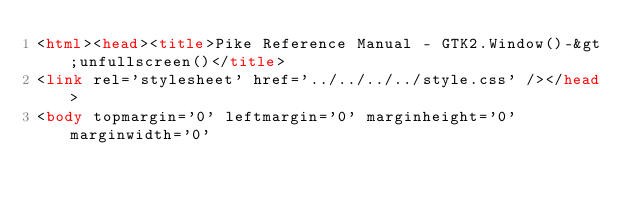<code> <loc_0><loc_0><loc_500><loc_500><_HTML_><html><head><title>Pike Reference Manual - GTK2.Window()-&gt;unfullscreen()</title>
<link rel='stylesheet' href='../../../../style.css' /></head>
<body topmargin='0' leftmargin='0' marginheight='0' marginwidth='0'</code> 